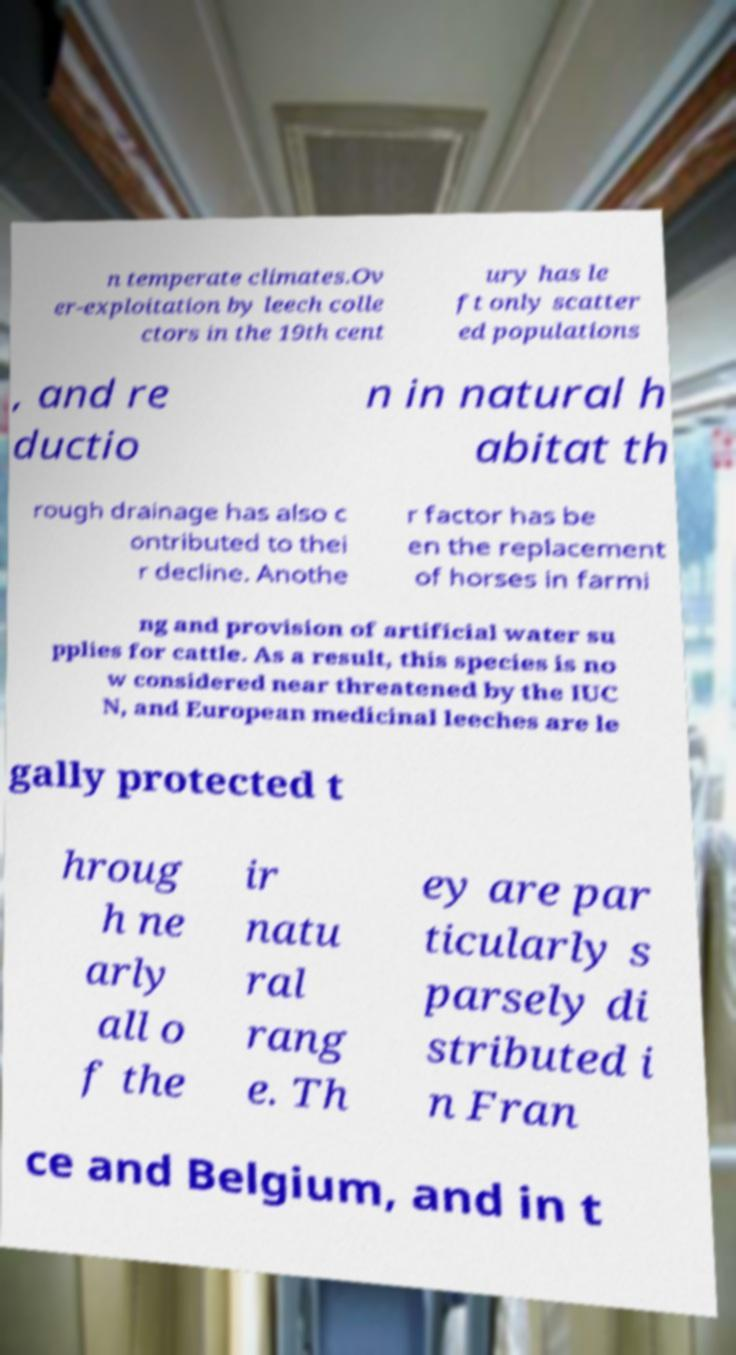What messages or text are displayed in this image? I need them in a readable, typed format. n temperate climates.Ov er-exploitation by leech colle ctors in the 19th cent ury has le ft only scatter ed populations , and re ductio n in natural h abitat th rough drainage has also c ontributed to thei r decline. Anothe r factor has be en the replacement of horses in farmi ng and provision of artificial water su pplies for cattle. As a result, this species is no w considered near threatened by the IUC N, and European medicinal leeches are le gally protected t hroug h ne arly all o f the ir natu ral rang e. Th ey are par ticularly s parsely di stributed i n Fran ce and Belgium, and in t 